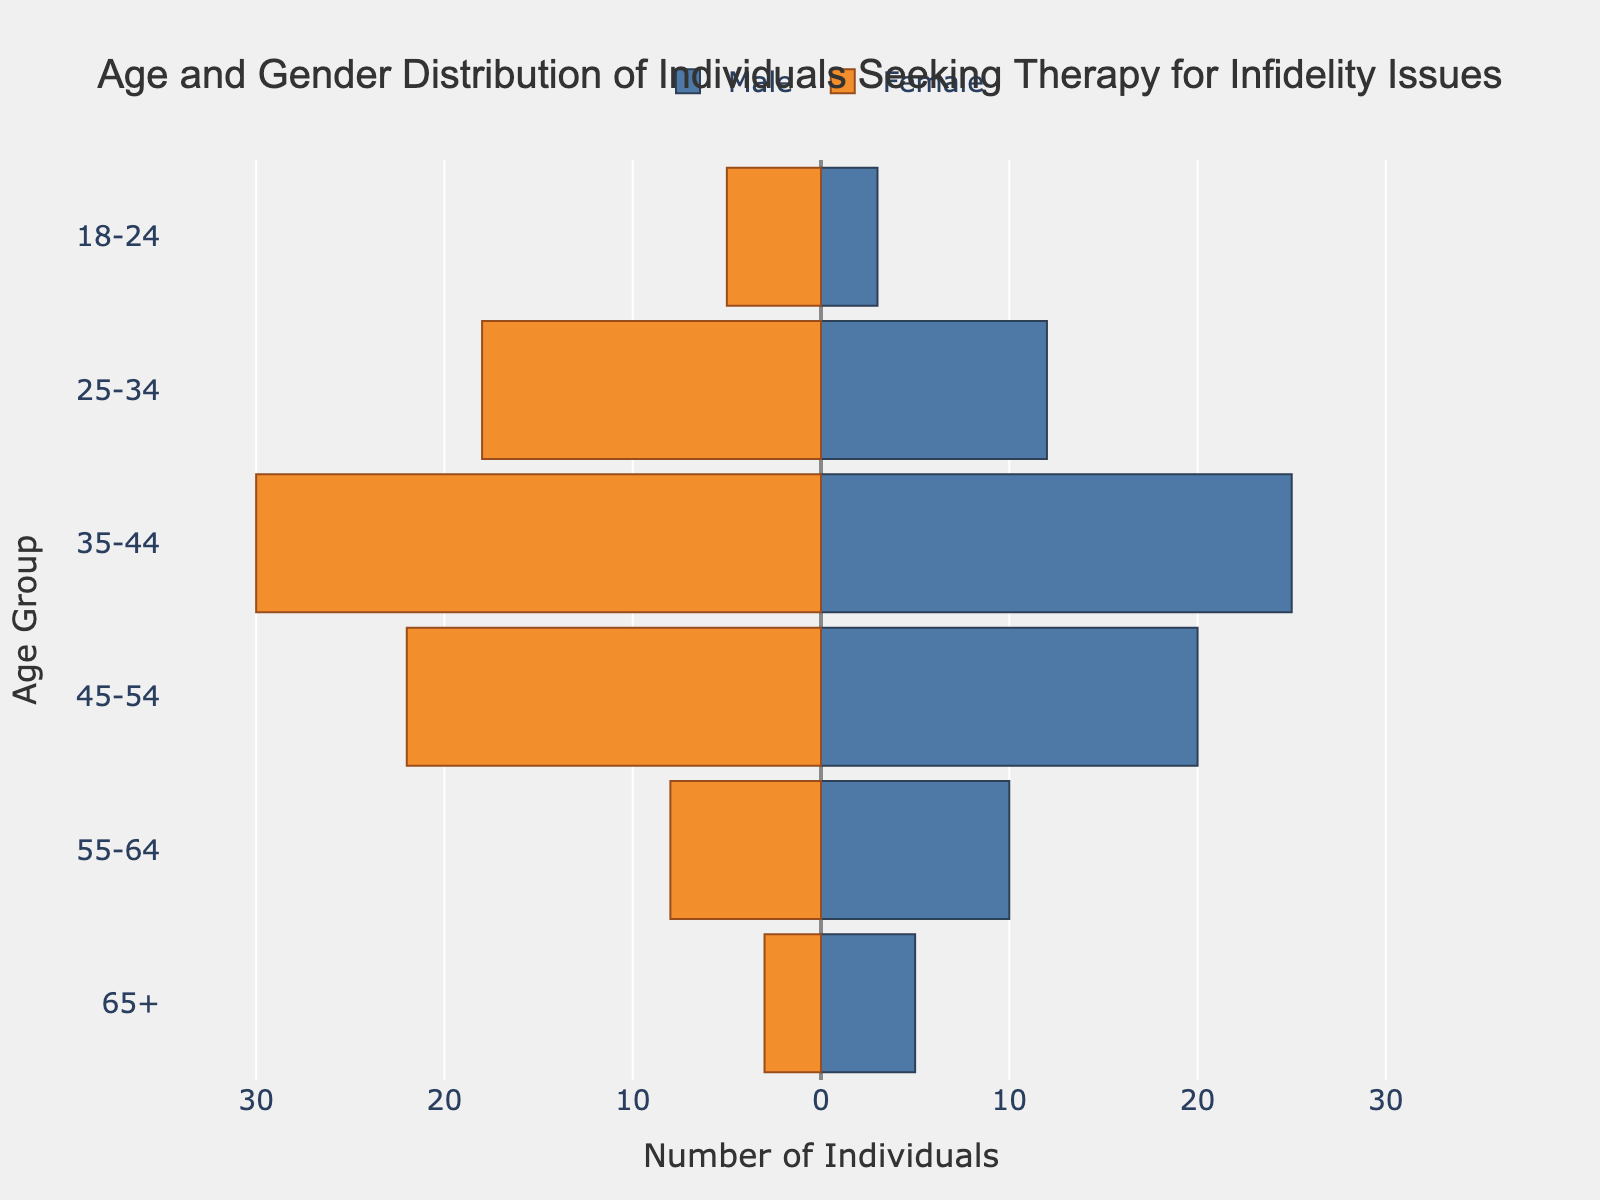what is the title of the figure? The title of the figure appears at the top and usually describes the main theme or the focus of the chart. It reads "Age and Gender Distribution of Individuals Seeking Therapy for Infidelity Issues."
Answer: Age and Gender Distribution of Individuals Seeking Therapy for Infidelity Issues How many females are in the 25-34 age group? To determine this, look at the length of the bar corresponding to the 25-34 age group on the female side of the pyramid. The length represents the number of individuals, which, in this case, is 18.
Answer: 18 Which age group has the highest number of males? By comparing the lengths of the male bars in all age groups, the 35-44 age group's bar is the longest, with a value of 25.
Answer: 35-44 What is the total number of individuals in the 45-54 age group? Add the number of males (20) and females (22) in the 45-54 age group. The sum is 20 males + 22 females = 42 individuals.
Answer: 42 Which gender has more individuals in the 55-64 age group? Compare the lengths of the bars for males and females in the 55-64 age group. The male bar is longer with a value of 10, while the female bar has a value of 8.
Answer: Male What is the difference between the number of males and females in the 35-44 age group? Subtract the number of females (30) from the number of males (25) in the 35-44 age group. The difference is 25 males - 30 females = -5.
Answer: -5 In which age group is the gender distribution the most balanced? Examine the lengths of the male and female bars in each age group and identify the one where the lengths are closest. The 45-54 age group has the closest values with males at 20 and females at 22.
Answer: 45-54 What percentage of the total number of individuals is in the 18-24 age group? First, find the total number of individuals (summation of all age groups). Then, calculate the sum for the 18-24 age group. Divide the sum of 18-24 (3 males + 5 females = 8) by the total sum (3 + 12 + 25 + 20 + 10 + 5 males + 5 + 18 + 30 + 22 + 8 + 3 females = 161) and multiply by 100 for the percentage. The calculation is (8/161)*100 ≈ 4.97%.
Answer: 4.97% Which gender has more individuals overall? Summing up the total number of males (3 + 12 + 25 + 20 + 10 + 5 = 75) and females (5 + 18 + 30 + 22 + 8 + 3 = 86). Comparing these totals, females have more individuals overall.
Answer: Female Which age group has the least number of individuals? Examine all the bars for each age group and identify the one with the smallest sum of males and females. The 18-24 age group has the least with a total of 8 (3 males + 5 females).
Answer: 18-24 